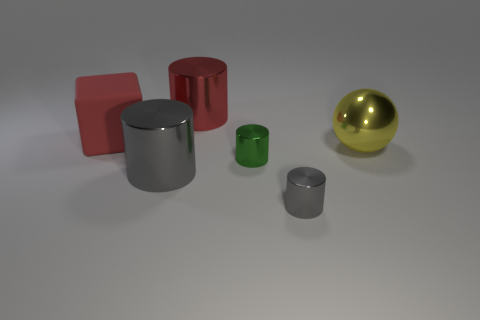Is the number of big gray metal cylinders that are on the left side of the rubber cube greater than the number of big yellow objects? no 